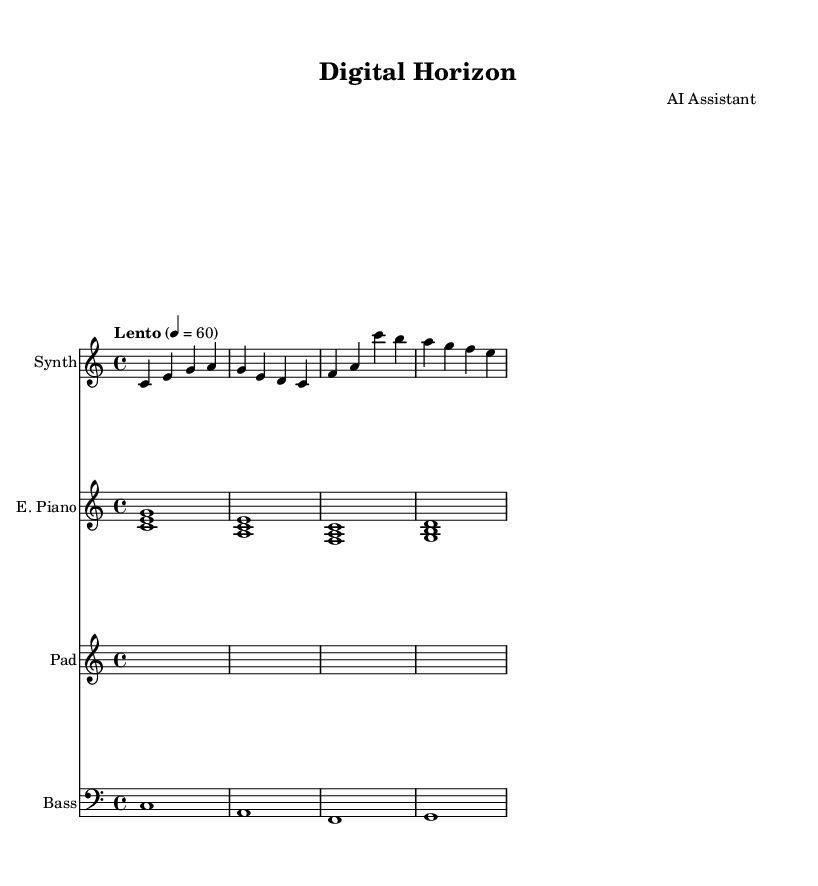What is the key signature of this music? The key signature is indicated at the beginning of the score. Since there are no sharps or flats shown, the key signature corresponds to C major.
Answer: C major What is the time signature of this piece? The time signature is found at the beginning of the score, where it shows 4/4, indicating four beats in a measure and a quarter note receives one beat.
Answer: 4/4 What is the tempo marking for this composition? The tempo marking is provided in a text instruction at the beginning of the score, stating "Lento" with a metronome marking of 60, which indicates a slow tempo.
Answer: Lento How many measures are there in the synthesizer part? Counting the measures in the synthesizer staff, there are four distinct measures, each separated by vertical lines.
Answer: 4 Which instrument plays the ambient pad? The instrument is identified by the staff with the title "Pad", showing that it belongs to the staff that plays the ambient pad part within the score.
Answer: Pad What chords are played in the electric piano part? The electric piano part contains three sets of chords noted as triads throughout the music, which are C major, A minor, and F major chords, respectively, in the sequence provided.
Answer: C major, A minor, F major What is the lowest note played in the bass part? In the bass staff, the notes are vertical and are listed in order with the lowest note being C, which is indicated at the beginning of the bass line as the first note.
Answer: C 